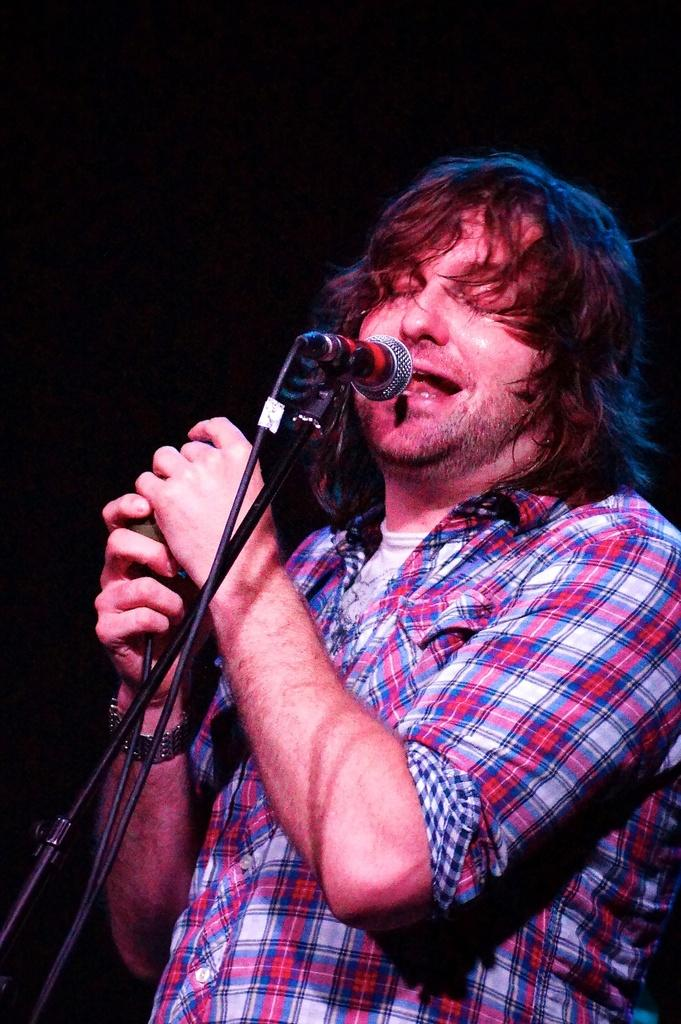Who is in the image? There is a person in the image. What is the person doing? The person is standing and singing a song. What object is in front of the person? There is a microphone in front of the person. What type of cracker is the person holding while singing in the image? There is no cracker present in the image; the person is holding a microphone while singing. Can you see any jellyfish in the image? No, there are no jellyfish present in the image. 